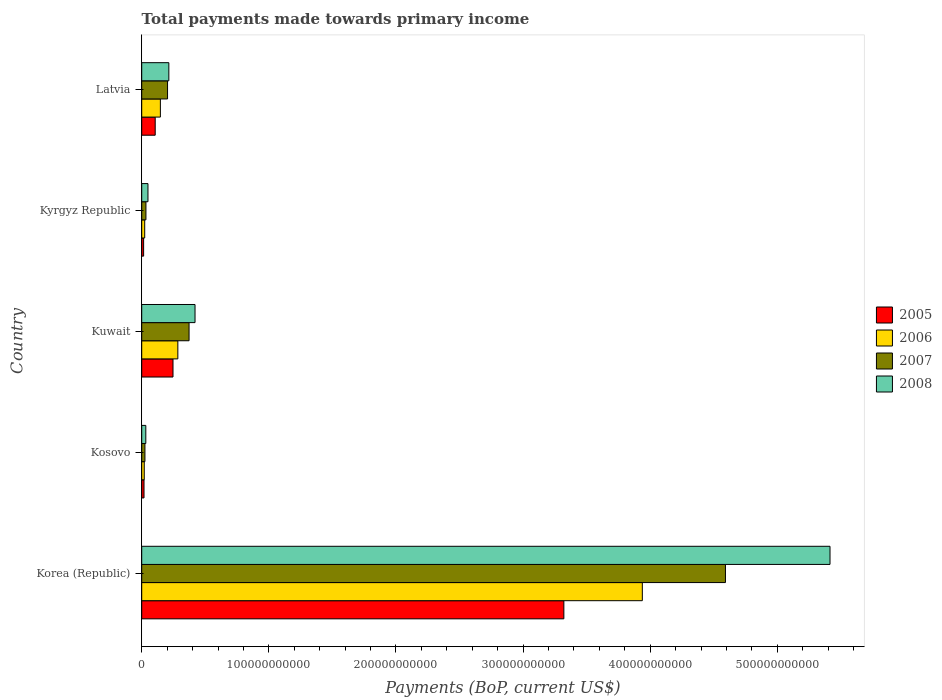How many different coloured bars are there?
Offer a very short reply. 4. How many groups of bars are there?
Ensure brevity in your answer.  5. Are the number of bars on each tick of the Y-axis equal?
Provide a short and direct response. Yes. How many bars are there on the 5th tick from the bottom?
Ensure brevity in your answer.  4. In how many cases, is the number of bars for a given country not equal to the number of legend labels?
Make the answer very short. 0. What is the total payments made towards primary income in 2006 in Kyrgyz Republic?
Ensure brevity in your answer.  2.34e+09. Across all countries, what is the maximum total payments made towards primary income in 2005?
Ensure brevity in your answer.  3.32e+11. Across all countries, what is the minimum total payments made towards primary income in 2007?
Provide a succinct answer. 2.53e+09. In which country was the total payments made towards primary income in 2006 minimum?
Your answer should be very brief. Kosovo. What is the total total payments made towards primary income in 2008 in the graph?
Offer a terse response. 6.13e+11. What is the difference between the total payments made towards primary income in 2007 in Kosovo and that in Latvia?
Keep it short and to the point. -1.78e+1. What is the difference between the total payments made towards primary income in 2005 in Korea (Republic) and the total payments made towards primary income in 2008 in Latvia?
Provide a succinct answer. 3.11e+11. What is the average total payments made towards primary income in 2006 per country?
Your answer should be compact. 8.82e+1. What is the difference between the total payments made towards primary income in 2006 and total payments made towards primary income in 2005 in Kyrgyz Republic?
Provide a short and direct response. 8.41e+08. What is the ratio of the total payments made towards primary income in 2008 in Korea (Republic) to that in Kuwait?
Your answer should be very brief. 12.91. Is the difference between the total payments made towards primary income in 2006 in Kosovo and Latvia greater than the difference between the total payments made towards primary income in 2005 in Kosovo and Latvia?
Keep it short and to the point. No. What is the difference between the highest and the second highest total payments made towards primary income in 2007?
Offer a very short reply. 4.22e+11. What is the difference between the highest and the lowest total payments made towards primary income in 2008?
Give a very brief answer. 5.38e+11. Is the sum of the total payments made towards primary income in 2008 in Kuwait and Latvia greater than the maximum total payments made towards primary income in 2006 across all countries?
Offer a very short reply. No. Is it the case that in every country, the sum of the total payments made towards primary income in 2005 and total payments made towards primary income in 2008 is greater than the sum of total payments made towards primary income in 2007 and total payments made towards primary income in 2006?
Your answer should be very brief. No. What does the 2nd bar from the bottom in Kosovo represents?
Offer a terse response. 2006. Is it the case that in every country, the sum of the total payments made towards primary income in 2008 and total payments made towards primary income in 2007 is greater than the total payments made towards primary income in 2005?
Offer a terse response. Yes. How many bars are there?
Your answer should be compact. 20. What is the difference between two consecutive major ticks on the X-axis?
Keep it short and to the point. 1.00e+11. Does the graph contain any zero values?
Give a very brief answer. No. Does the graph contain grids?
Your answer should be very brief. No. How are the legend labels stacked?
Provide a short and direct response. Vertical. What is the title of the graph?
Your answer should be very brief. Total payments made towards primary income. What is the label or title of the X-axis?
Your answer should be very brief. Payments (BoP, current US$). What is the label or title of the Y-axis?
Your answer should be compact. Country. What is the Payments (BoP, current US$) in 2005 in Korea (Republic)?
Keep it short and to the point. 3.32e+11. What is the Payments (BoP, current US$) in 2006 in Korea (Republic)?
Offer a very short reply. 3.94e+11. What is the Payments (BoP, current US$) in 2007 in Korea (Republic)?
Make the answer very short. 4.59e+11. What is the Payments (BoP, current US$) of 2008 in Korea (Republic)?
Make the answer very short. 5.41e+11. What is the Payments (BoP, current US$) of 2005 in Kosovo?
Give a very brief answer. 1.80e+09. What is the Payments (BoP, current US$) of 2006 in Kosovo?
Your answer should be compact. 1.99e+09. What is the Payments (BoP, current US$) in 2007 in Kosovo?
Provide a succinct answer. 2.53e+09. What is the Payments (BoP, current US$) of 2008 in Kosovo?
Offer a terse response. 3.22e+09. What is the Payments (BoP, current US$) in 2005 in Kuwait?
Provide a succinct answer. 2.46e+1. What is the Payments (BoP, current US$) in 2006 in Kuwait?
Ensure brevity in your answer.  2.84e+1. What is the Payments (BoP, current US$) of 2007 in Kuwait?
Offer a terse response. 3.72e+1. What is the Payments (BoP, current US$) in 2008 in Kuwait?
Provide a succinct answer. 4.19e+1. What is the Payments (BoP, current US$) of 2005 in Kyrgyz Republic?
Offer a very short reply. 1.50e+09. What is the Payments (BoP, current US$) in 2006 in Kyrgyz Republic?
Ensure brevity in your answer.  2.34e+09. What is the Payments (BoP, current US$) in 2007 in Kyrgyz Republic?
Provide a short and direct response. 3.31e+09. What is the Payments (BoP, current US$) in 2008 in Kyrgyz Republic?
Provide a succinct answer. 4.91e+09. What is the Payments (BoP, current US$) of 2005 in Latvia?
Offer a terse response. 1.06e+1. What is the Payments (BoP, current US$) in 2006 in Latvia?
Provide a succinct answer. 1.47e+1. What is the Payments (BoP, current US$) of 2007 in Latvia?
Keep it short and to the point. 2.03e+1. What is the Payments (BoP, current US$) in 2008 in Latvia?
Your answer should be compact. 2.13e+1. Across all countries, what is the maximum Payments (BoP, current US$) of 2005?
Provide a succinct answer. 3.32e+11. Across all countries, what is the maximum Payments (BoP, current US$) of 2006?
Provide a short and direct response. 3.94e+11. Across all countries, what is the maximum Payments (BoP, current US$) in 2007?
Give a very brief answer. 4.59e+11. Across all countries, what is the maximum Payments (BoP, current US$) in 2008?
Ensure brevity in your answer.  5.41e+11. Across all countries, what is the minimum Payments (BoP, current US$) in 2005?
Provide a short and direct response. 1.50e+09. Across all countries, what is the minimum Payments (BoP, current US$) in 2006?
Make the answer very short. 1.99e+09. Across all countries, what is the minimum Payments (BoP, current US$) of 2007?
Provide a succinct answer. 2.53e+09. Across all countries, what is the minimum Payments (BoP, current US$) in 2008?
Your response must be concise. 3.22e+09. What is the total Payments (BoP, current US$) in 2005 in the graph?
Your answer should be very brief. 3.71e+11. What is the total Payments (BoP, current US$) of 2006 in the graph?
Ensure brevity in your answer.  4.41e+11. What is the total Payments (BoP, current US$) of 2007 in the graph?
Give a very brief answer. 5.23e+11. What is the total Payments (BoP, current US$) in 2008 in the graph?
Provide a short and direct response. 6.13e+11. What is the difference between the Payments (BoP, current US$) in 2005 in Korea (Republic) and that in Kosovo?
Make the answer very short. 3.30e+11. What is the difference between the Payments (BoP, current US$) in 2006 in Korea (Republic) and that in Kosovo?
Give a very brief answer. 3.92e+11. What is the difference between the Payments (BoP, current US$) in 2007 in Korea (Republic) and that in Kosovo?
Make the answer very short. 4.57e+11. What is the difference between the Payments (BoP, current US$) of 2008 in Korea (Republic) and that in Kosovo?
Give a very brief answer. 5.38e+11. What is the difference between the Payments (BoP, current US$) in 2005 in Korea (Republic) and that in Kuwait?
Offer a terse response. 3.07e+11. What is the difference between the Payments (BoP, current US$) of 2006 in Korea (Republic) and that in Kuwait?
Make the answer very short. 3.65e+11. What is the difference between the Payments (BoP, current US$) of 2007 in Korea (Republic) and that in Kuwait?
Your answer should be very brief. 4.22e+11. What is the difference between the Payments (BoP, current US$) in 2008 in Korea (Republic) and that in Kuwait?
Make the answer very short. 5.00e+11. What is the difference between the Payments (BoP, current US$) of 2005 in Korea (Republic) and that in Kyrgyz Republic?
Make the answer very short. 3.31e+11. What is the difference between the Payments (BoP, current US$) in 2006 in Korea (Republic) and that in Kyrgyz Republic?
Ensure brevity in your answer.  3.91e+11. What is the difference between the Payments (BoP, current US$) in 2007 in Korea (Republic) and that in Kyrgyz Republic?
Offer a very short reply. 4.56e+11. What is the difference between the Payments (BoP, current US$) of 2008 in Korea (Republic) and that in Kyrgyz Republic?
Offer a terse response. 5.37e+11. What is the difference between the Payments (BoP, current US$) in 2005 in Korea (Republic) and that in Latvia?
Offer a terse response. 3.21e+11. What is the difference between the Payments (BoP, current US$) of 2006 in Korea (Republic) and that in Latvia?
Give a very brief answer. 3.79e+11. What is the difference between the Payments (BoP, current US$) of 2007 in Korea (Republic) and that in Latvia?
Your answer should be compact. 4.39e+11. What is the difference between the Payments (BoP, current US$) of 2008 in Korea (Republic) and that in Latvia?
Provide a short and direct response. 5.20e+11. What is the difference between the Payments (BoP, current US$) in 2005 in Kosovo and that in Kuwait?
Your answer should be very brief. -2.28e+1. What is the difference between the Payments (BoP, current US$) of 2006 in Kosovo and that in Kuwait?
Your response must be concise. -2.64e+1. What is the difference between the Payments (BoP, current US$) in 2007 in Kosovo and that in Kuwait?
Keep it short and to the point. -3.47e+1. What is the difference between the Payments (BoP, current US$) of 2008 in Kosovo and that in Kuwait?
Your answer should be very brief. -3.87e+1. What is the difference between the Payments (BoP, current US$) in 2005 in Kosovo and that in Kyrgyz Republic?
Offer a terse response. 3.03e+08. What is the difference between the Payments (BoP, current US$) of 2006 in Kosovo and that in Kyrgyz Republic?
Provide a succinct answer. -3.55e+08. What is the difference between the Payments (BoP, current US$) of 2007 in Kosovo and that in Kyrgyz Republic?
Your answer should be compact. -7.83e+08. What is the difference between the Payments (BoP, current US$) of 2008 in Kosovo and that in Kyrgyz Republic?
Make the answer very short. -1.69e+09. What is the difference between the Payments (BoP, current US$) of 2005 in Kosovo and that in Latvia?
Provide a succinct answer. -8.80e+09. What is the difference between the Payments (BoP, current US$) in 2006 in Kosovo and that in Latvia?
Ensure brevity in your answer.  -1.27e+1. What is the difference between the Payments (BoP, current US$) of 2007 in Kosovo and that in Latvia?
Keep it short and to the point. -1.78e+1. What is the difference between the Payments (BoP, current US$) of 2008 in Kosovo and that in Latvia?
Offer a very short reply. -1.81e+1. What is the difference between the Payments (BoP, current US$) in 2005 in Kuwait and that in Kyrgyz Republic?
Your response must be concise. 2.31e+1. What is the difference between the Payments (BoP, current US$) of 2006 in Kuwait and that in Kyrgyz Republic?
Ensure brevity in your answer.  2.61e+1. What is the difference between the Payments (BoP, current US$) in 2007 in Kuwait and that in Kyrgyz Republic?
Ensure brevity in your answer.  3.39e+1. What is the difference between the Payments (BoP, current US$) of 2008 in Kuwait and that in Kyrgyz Republic?
Offer a very short reply. 3.70e+1. What is the difference between the Payments (BoP, current US$) in 2005 in Kuwait and that in Latvia?
Offer a terse response. 1.40e+1. What is the difference between the Payments (BoP, current US$) of 2006 in Kuwait and that in Latvia?
Make the answer very short. 1.37e+1. What is the difference between the Payments (BoP, current US$) in 2007 in Kuwait and that in Latvia?
Make the answer very short. 1.69e+1. What is the difference between the Payments (BoP, current US$) of 2008 in Kuwait and that in Latvia?
Provide a short and direct response. 2.06e+1. What is the difference between the Payments (BoP, current US$) in 2005 in Kyrgyz Republic and that in Latvia?
Ensure brevity in your answer.  -9.11e+09. What is the difference between the Payments (BoP, current US$) of 2006 in Kyrgyz Republic and that in Latvia?
Your answer should be compact. -1.23e+1. What is the difference between the Payments (BoP, current US$) in 2007 in Kyrgyz Republic and that in Latvia?
Make the answer very short. -1.70e+1. What is the difference between the Payments (BoP, current US$) in 2008 in Kyrgyz Republic and that in Latvia?
Your response must be concise. -1.64e+1. What is the difference between the Payments (BoP, current US$) of 2005 in Korea (Republic) and the Payments (BoP, current US$) of 2006 in Kosovo?
Make the answer very short. 3.30e+11. What is the difference between the Payments (BoP, current US$) in 2005 in Korea (Republic) and the Payments (BoP, current US$) in 2007 in Kosovo?
Ensure brevity in your answer.  3.30e+11. What is the difference between the Payments (BoP, current US$) of 2005 in Korea (Republic) and the Payments (BoP, current US$) of 2008 in Kosovo?
Give a very brief answer. 3.29e+11. What is the difference between the Payments (BoP, current US$) in 2006 in Korea (Republic) and the Payments (BoP, current US$) in 2007 in Kosovo?
Keep it short and to the point. 3.91e+11. What is the difference between the Payments (BoP, current US$) of 2006 in Korea (Republic) and the Payments (BoP, current US$) of 2008 in Kosovo?
Your response must be concise. 3.91e+11. What is the difference between the Payments (BoP, current US$) in 2007 in Korea (Republic) and the Payments (BoP, current US$) in 2008 in Kosovo?
Your response must be concise. 4.56e+11. What is the difference between the Payments (BoP, current US$) in 2005 in Korea (Republic) and the Payments (BoP, current US$) in 2006 in Kuwait?
Your answer should be very brief. 3.04e+11. What is the difference between the Payments (BoP, current US$) of 2005 in Korea (Republic) and the Payments (BoP, current US$) of 2007 in Kuwait?
Your response must be concise. 2.95e+11. What is the difference between the Payments (BoP, current US$) in 2005 in Korea (Republic) and the Payments (BoP, current US$) in 2008 in Kuwait?
Your answer should be compact. 2.90e+11. What is the difference between the Payments (BoP, current US$) in 2006 in Korea (Republic) and the Payments (BoP, current US$) in 2007 in Kuwait?
Give a very brief answer. 3.57e+11. What is the difference between the Payments (BoP, current US$) of 2006 in Korea (Republic) and the Payments (BoP, current US$) of 2008 in Kuwait?
Offer a very short reply. 3.52e+11. What is the difference between the Payments (BoP, current US$) of 2007 in Korea (Republic) and the Payments (BoP, current US$) of 2008 in Kuwait?
Provide a short and direct response. 4.17e+11. What is the difference between the Payments (BoP, current US$) of 2005 in Korea (Republic) and the Payments (BoP, current US$) of 2006 in Kyrgyz Republic?
Your answer should be very brief. 3.30e+11. What is the difference between the Payments (BoP, current US$) of 2005 in Korea (Republic) and the Payments (BoP, current US$) of 2007 in Kyrgyz Republic?
Offer a very short reply. 3.29e+11. What is the difference between the Payments (BoP, current US$) of 2005 in Korea (Republic) and the Payments (BoP, current US$) of 2008 in Kyrgyz Republic?
Give a very brief answer. 3.27e+11. What is the difference between the Payments (BoP, current US$) in 2006 in Korea (Republic) and the Payments (BoP, current US$) in 2007 in Kyrgyz Republic?
Provide a succinct answer. 3.91e+11. What is the difference between the Payments (BoP, current US$) of 2006 in Korea (Republic) and the Payments (BoP, current US$) of 2008 in Kyrgyz Republic?
Offer a very short reply. 3.89e+11. What is the difference between the Payments (BoP, current US$) in 2007 in Korea (Republic) and the Payments (BoP, current US$) in 2008 in Kyrgyz Republic?
Your response must be concise. 4.54e+11. What is the difference between the Payments (BoP, current US$) of 2005 in Korea (Republic) and the Payments (BoP, current US$) of 2006 in Latvia?
Provide a succinct answer. 3.17e+11. What is the difference between the Payments (BoP, current US$) in 2005 in Korea (Republic) and the Payments (BoP, current US$) in 2007 in Latvia?
Provide a short and direct response. 3.12e+11. What is the difference between the Payments (BoP, current US$) in 2005 in Korea (Republic) and the Payments (BoP, current US$) in 2008 in Latvia?
Provide a succinct answer. 3.11e+11. What is the difference between the Payments (BoP, current US$) in 2006 in Korea (Republic) and the Payments (BoP, current US$) in 2007 in Latvia?
Provide a succinct answer. 3.74e+11. What is the difference between the Payments (BoP, current US$) of 2006 in Korea (Republic) and the Payments (BoP, current US$) of 2008 in Latvia?
Make the answer very short. 3.72e+11. What is the difference between the Payments (BoP, current US$) of 2007 in Korea (Republic) and the Payments (BoP, current US$) of 2008 in Latvia?
Make the answer very short. 4.38e+11. What is the difference between the Payments (BoP, current US$) of 2005 in Kosovo and the Payments (BoP, current US$) of 2006 in Kuwait?
Offer a very short reply. -2.66e+1. What is the difference between the Payments (BoP, current US$) in 2005 in Kosovo and the Payments (BoP, current US$) in 2007 in Kuwait?
Your answer should be compact. -3.54e+1. What is the difference between the Payments (BoP, current US$) in 2005 in Kosovo and the Payments (BoP, current US$) in 2008 in Kuwait?
Make the answer very short. -4.01e+1. What is the difference between the Payments (BoP, current US$) of 2006 in Kosovo and the Payments (BoP, current US$) of 2007 in Kuwait?
Provide a succinct answer. -3.53e+1. What is the difference between the Payments (BoP, current US$) of 2006 in Kosovo and the Payments (BoP, current US$) of 2008 in Kuwait?
Give a very brief answer. -3.99e+1. What is the difference between the Payments (BoP, current US$) of 2007 in Kosovo and the Payments (BoP, current US$) of 2008 in Kuwait?
Provide a short and direct response. -3.94e+1. What is the difference between the Payments (BoP, current US$) of 2005 in Kosovo and the Payments (BoP, current US$) of 2006 in Kyrgyz Republic?
Your response must be concise. -5.39e+08. What is the difference between the Payments (BoP, current US$) of 2005 in Kosovo and the Payments (BoP, current US$) of 2007 in Kyrgyz Republic?
Your response must be concise. -1.51e+09. What is the difference between the Payments (BoP, current US$) of 2005 in Kosovo and the Payments (BoP, current US$) of 2008 in Kyrgyz Republic?
Your answer should be very brief. -3.11e+09. What is the difference between the Payments (BoP, current US$) of 2006 in Kosovo and the Payments (BoP, current US$) of 2007 in Kyrgyz Republic?
Provide a short and direct response. -1.32e+09. What is the difference between the Payments (BoP, current US$) of 2006 in Kosovo and the Payments (BoP, current US$) of 2008 in Kyrgyz Republic?
Your answer should be very brief. -2.93e+09. What is the difference between the Payments (BoP, current US$) in 2007 in Kosovo and the Payments (BoP, current US$) in 2008 in Kyrgyz Republic?
Offer a very short reply. -2.38e+09. What is the difference between the Payments (BoP, current US$) in 2005 in Kosovo and the Payments (BoP, current US$) in 2006 in Latvia?
Give a very brief answer. -1.29e+1. What is the difference between the Payments (BoP, current US$) of 2005 in Kosovo and the Payments (BoP, current US$) of 2007 in Latvia?
Offer a terse response. -1.85e+1. What is the difference between the Payments (BoP, current US$) in 2005 in Kosovo and the Payments (BoP, current US$) in 2008 in Latvia?
Ensure brevity in your answer.  -1.95e+1. What is the difference between the Payments (BoP, current US$) in 2006 in Kosovo and the Payments (BoP, current US$) in 2007 in Latvia?
Keep it short and to the point. -1.83e+1. What is the difference between the Payments (BoP, current US$) of 2006 in Kosovo and the Payments (BoP, current US$) of 2008 in Latvia?
Offer a very short reply. -1.93e+1. What is the difference between the Payments (BoP, current US$) of 2007 in Kosovo and the Payments (BoP, current US$) of 2008 in Latvia?
Your response must be concise. -1.88e+1. What is the difference between the Payments (BoP, current US$) of 2005 in Kuwait and the Payments (BoP, current US$) of 2006 in Kyrgyz Republic?
Provide a succinct answer. 2.23e+1. What is the difference between the Payments (BoP, current US$) of 2005 in Kuwait and the Payments (BoP, current US$) of 2007 in Kyrgyz Republic?
Your answer should be very brief. 2.13e+1. What is the difference between the Payments (BoP, current US$) in 2005 in Kuwait and the Payments (BoP, current US$) in 2008 in Kyrgyz Republic?
Offer a very short reply. 1.97e+1. What is the difference between the Payments (BoP, current US$) of 2006 in Kuwait and the Payments (BoP, current US$) of 2007 in Kyrgyz Republic?
Provide a short and direct response. 2.51e+1. What is the difference between the Payments (BoP, current US$) of 2006 in Kuwait and the Payments (BoP, current US$) of 2008 in Kyrgyz Republic?
Provide a short and direct response. 2.35e+1. What is the difference between the Payments (BoP, current US$) of 2007 in Kuwait and the Payments (BoP, current US$) of 2008 in Kyrgyz Republic?
Your answer should be very brief. 3.23e+1. What is the difference between the Payments (BoP, current US$) of 2005 in Kuwait and the Payments (BoP, current US$) of 2006 in Latvia?
Make the answer very short. 9.93e+09. What is the difference between the Payments (BoP, current US$) in 2005 in Kuwait and the Payments (BoP, current US$) in 2007 in Latvia?
Provide a succinct answer. 4.30e+09. What is the difference between the Payments (BoP, current US$) in 2005 in Kuwait and the Payments (BoP, current US$) in 2008 in Latvia?
Provide a succinct answer. 3.28e+09. What is the difference between the Payments (BoP, current US$) of 2006 in Kuwait and the Payments (BoP, current US$) of 2007 in Latvia?
Provide a short and direct response. 8.10e+09. What is the difference between the Payments (BoP, current US$) in 2006 in Kuwait and the Payments (BoP, current US$) in 2008 in Latvia?
Ensure brevity in your answer.  7.08e+09. What is the difference between the Payments (BoP, current US$) in 2007 in Kuwait and the Payments (BoP, current US$) in 2008 in Latvia?
Your response must be concise. 1.59e+1. What is the difference between the Payments (BoP, current US$) in 2005 in Kyrgyz Republic and the Payments (BoP, current US$) in 2006 in Latvia?
Give a very brief answer. -1.32e+1. What is the difference between the Payments (BoP, current US$) in 2005 in Kyrgyz Republic and the Payments (BoP, current US$) in 2007 in Latvia?
Keep it short and to the point. -1.88e+1. What is the difference between the Payments (BoP, current US$) in 2005 in Kyrgyz Republic and the Payments (BoP, current US$) in 2008 in Latvia?
Offer a terse response. -1.98e+1. What is the difference between the Payments (BoP, current US$) in 2006 in Kyrgyz Republic and the Payments (BoP, current US$) in 2007 in Latvia?
Provide a succinct answer. -1.80e+1. What is the difference between the Payments (BoP, current US$) in 2006 in Kyrgyz Republic and the Payments (BoP, current US$) in 2008 in Latvia?
Offer a very short reply. -1.90e+1. What is the difference between the Payments (BoP, current US$) in 2007 in Kyrgyz Republic and the Payments (BoP, current US$) in 2008 in Latvia?
Offer a very short reply. -1.80e+1. What is the average Payments (BoP, current US$) in 2005 per country?
Your answer should be compact. 7.41e+1. What is the average Payments (BoP, current US$) in 2006 per country?
Offer a terse response. 8.82e+1. What is the average Payments (BoP, current US$) of 2007 per country?
Keep it short and to the point. 1.05e+11. What is the average Payments (BoP, current US$) in 2008 per country?
Your answer should be compact. 1.23e+11. What is the difference between the Payments (BoP, current US$) in 2005 and Payments (BoP, current US$) in 2006 in Korea (Republic)?
Offer a very short reply. -6.17e+1. What is the difference between the Payments (BoP, current US$) of 2005 and Payments (BoP, current US$) of 2007 in Korea (Republic)?
Your response must be concise. -1.27e+11. What is the difference between the Payments (BoP, current US$) in 2005 and Payments (BoP, current US$) in 2008 in Korea (Republic)?
Give a very brief answer. -2.09e+11. What is the difference between the Payments (BoP, current US$) of 2006 and Payments (BoP, current US$) of 2007 in Korea (Republic)?
Ensure brevity in your answer.  -6.54e+1. What is the difference between the Payments (BoP, current US$) in 2006 and Payments (BoP, current US$) in 2008 in Korea (Republic)?
Offer a terse response. -1.48e+11. What is the difference between the Payments (BoP, current US$) of 2007 and Payments (BoP, current US$) of 2008 in Korea (Republic)?
Offer a terse response. -8.22e+1. What is the difference between the Payments (BoP, current US$) in 2005 and Payments (BoP, current US$) in 2006 in Kosovo?
Provide a succinct answer. -1.83e+08. What is the difference between the Payments (BoP, current US$) in 2005 and Payments (BoP, current US$) in 2007 in Kosovo?
Provide a succinct answer. -7.24e+08. What is the difference between the Payments (BoP, current US$) in 2005 and Payments (BoP, current US$) in 2008 in Kosovo?
Make the answer very short. -1.42e+09. What is the difference between the Payments (BoP, current US$) in 2006 and Payments (BoP, current US$) in 2007 in Kosovo?
Keep it short and to the point. -5.41e+08. What is the difference between the Payments (BoP, current US$) in 2006 and Payments (BoP, current US$) in 2008 in Kosovo?
Offer a very short reply. -1.24e+09. What is the difference between the Payments (BoP, current US$) of 2007 and Payments (BoP, current US$) of 2008 in Kosovo?
Your answer should be compact. -6.94e+08. What is the difference between the Payments (BoP, current US$) of 2005 and Payments (BoP, current US$) of 2006 in Kuwait?
Provide a succinct answer. -3.80e+09. What is the difference between the Payments (BoP, current US$) of 2005 and Payments (BoP, current US$) of 2007 in Kuwait?
Your answer should be very brief. -1.26e+1. What is the difference between the Payments (BoP, current US$) in 2005 and Payments (BoP, current US$) in 2008 in Kuwait?
Keep it short and to the point. -1.73e+1. What is the difference between the Payments (BoP, current US$) of 2006 and Payments (BoP, current US$) of 2007 in Kuwait?
Ensure brevity in your answer.  -8.83e+09. What is the difference between the Payments (BoP, current US$) in 2006 and Payments (BoP, current US$) in 2008 in Kuwait?
Your response must be concise. -1.35e+1. What is the difference between the Payments (BoP, current US$) of 2007 and Payments (BoP, current US$) of 2008 in Kuwait?
Provide a succinct answer. -4.70e+09. What is the difference between the Payments (BoP, current US$) in 2005 and Payments (BoP, current US$) in 2006 in Kyrgyz Republic?
Make the answer very short. -8.41e+08. What is the difference between the Payments (BoP, current US$) in 2005 and Payments (BoP, current US$) in 2007 in Kyrgyz Republic?
Offer a terse response. -1.81e+09. What is the difference between the Payments (BoP, current US$) in 2005 and Payments (BoP, current US$) in 2008 in Kyrgyz Republic?
Offer a terse response. -3.41e+09. What is the difference between the Payments (BoP, current US$) in 2006 and Payments (BoP, current US$) in 2007 in Kyrgyz Republic?
Provide a succinct answer. -9.69e+08. What is the difference between the Payments (BoP, current US$) in 2006 and Payments (BoP, current US$) in 2008 in Kyrgyz Republic?
Ensure brevity in your answer.  -2.57e+09. What is the difference between the Payments (BoP, current US$) in 2007 and Payments (BoP, current US$) in 2008 in Kyrgyz Republic?
Your answer should be compact. -1.60e+09. What is the difference between the Payments (BoP, current US$) in 2005 and Payments (BoP, current US$) in 2006 in Latvia?
Your answer should be compact. -4.07e+09. What is the difference between the Payments (BoP, current US$) of 2005 and Payments (BoP, current US$) of 2007 in Latvia?
Provide a succinct answer. -9.71e+09. What is the difference between the Payments (BoP, current US$) in 2005 and Payments (BoP, current US$) in 2008 in Latvia?
Your response must be concise. -1.07e+1. What is the difference between the Payments (BoP, current US$) of 2006 and Payments (BoP, current US$) of 2007 in Latvia?
Make the answer very short. -5.63e+09. What is the difference between the Payments (BoP, current US$) in 2006 and Payments (BoP, current US$) in 2008 in Latvia?
Make the answer very short. -6.65e+09. What is the difference between the Payments (BoP, current US$) in 2007 and Payments (BoP, current US$) in 2008 in Latvia?
Your response must be concise. -1.02e+09. What is the ratio of the Payments (BoP, current US$) in 2005 in Korea (Republic) to that in Kosovo?
Keep it short and to the point. 184.13. What is the ratio of the Payments (BoP, current US$) in 2006 in Korea (Republic) to that in Kosovo?
Give a very brief answer. 198.25. What is the ratio of the Payments (BoP, current US$) in 2007 in Korea (Republic) to that in Kosovo?
Give a very brief answer. 181.66. What is the ratio of the Payments (BoP, current US$) in 2008 in Korea (Republic) to that in Kosovo?
Keep it short and to the point. 168.03. What is the ratio of the Payments (BoP, current US$) of 2005 in Korea (Republic) to that in Kuwait?
Keep it short and to the point. 13.49. What is the ratio of the Payments (BoP, current US$) of 2006 in Korea (Republic) to that in Kuwait?
Offer a terse response. 13.86. What is the ratio of the Payments (BoP, current US$) in 2007 in Korea (Republic) to that in Kuwait?
Provide a short and direct response. 12.33. What is the ratio of the Payments (BoP, current US$) of 2008 in Korea (Republic) to that in Kuwait?
Keep it short and to the point. 12.91. What is the ratio of the Payments (BoP, current US$) of 2005 in Korea (Republic) to that in Kyrgyz Republic?
Keep it short and to the point. 221.31. What is the ratio of the Payments (BoP, current US$) in 2006 in Korea (Republic) to that in Kyrgyz Republic?
Provide a short and direct response. 168.16. What is the ratio of the Payments (BoP, current US$) of 2007 in Korea (Republic) to that in Kyrgyz Republic?
Your answer should be very brief. 138.68. What is the ratio of the Payments (BoP, current US$) in 2008 in Korea (Republic) to that in Kyrgyz Republic?
Provide a succinct answer. 110.24. What is the ratio of the Payments (BoP, current US$) of 2005 in Korea (Republic) to that in Latvia?
Provide a succinct answer. 31.31. What is the ratio of the Payments (BoP, current US$) in 2006 in Korea (Republic) to that in Latvia?
Give a very brief answer. 26.83. What is the ratio of the Payments (BoP, current US$) of 2007 in Korea (Republic) to that in Latvia?
Keep it short and to the point. 22.61. What is the ratio of the Payments (BoP, current US$) in 2008 in Korea (Republic) to that in Latvia?
Offer a very short reply. 25.38. What is the ratio of the Payments (BoP, current US$) of 2005 in Kosovo to that in Kuwait?
Your answer should be very brief. 0.07. What is the ratio of the Payments (BoP, current US$) of 2006 in Kosovo to that in Kuwait?
Your answer should be compact. 0.07. What is the ratio of the Payments (BoP, current US$) of 2007 in Kosovo to that in Kuwait?
Your answer should be very brief. 0.07. What is the ratio of the Payments (BoP, current US$) in 2008 in Kosovo to that in Kuwait?
Make the answer very short. 0.08. What is the ratio of the Payments (BoP, current US$) of 2005 in Kosovo to that in Kyrgyz Republic?
Offer a very short reply. 1.2. What is the ratio of the Payments (BoP, current US$) in 2006 in Kosovo to that in Kyrgyz Republic?
Ensure brevity in your answer.  0.85. What is the ratio of the Payments (BoP, current US$) in 2007 in Kosovo to that in Kyrgyz Republic?
Ensure brevity in your answer.  0.76. What is the ratio of the Payments (BoP, current US$) of 2008 in Kosovo to that in Kyrgyz Republic?
Your answer should be very brief. 0.66. What is the ratio of the Payments (BoP, current US$) in 2005 in Kosovo to that in Latvia?
Give a very brief answer. 0.17. What is the ratio of the Payments (BoP, current US$) of 2006 in Kosovo to that in Latvia?
Provide a short and direct response. 0.14. What is the ratio of the Payments (BoP, current US$) of 2007 in Kosovo to that in Latvia?
Your response must be concise. 0.12. What is the ratio of the Payments (BoP, current US$) in 2008 in Kosovo to that in Latvia?
Provide a succinct answer. 0.15. What is the ratio of the Payments (BoP, current US$) of 2005 in Kuwait to that in Kyrgyz Republic?
Offer a terse response. 16.4. What is the ratio of the Payments (BoP, current US$) of 2006 in Kuwait to that in Kyrgyz Republic?
Provide a short and direct response. 12.13. What is the ratio of the Payments (BoP, current US$) in 2007 in Kuwait to that in Kyrgyz Republic?
Provide a succinct answer. 11.25. What is the ratio of the Payments (BoP, current US$) of 2008 in Kuwait to that in Kyrgyz Republic?
Ensure brevity in your answer.  8.54. What is the ratio of the Payments (BoP, current US$) in 2005 in Kuwait to that in Latvia?
Provide a succinct answer. 2.32. What is the ratio of the Payments (BoP, current US$) in 2006 in Kuwait to that in Latvia?
Offer a terse response. 1.94. What is the ratio of the Payments (BoP, current US$) of 2007 in Kuwait to that in Latvia?
Give a very brief answer. 1.83. What is the ratio of the Payments (BoP, current US$) of 2008 in Kuwait to that in Latvia?
Offer a very short reply. 1.97. What is the ratio of the Payments (BoP, current US$) in 2005 in Kyrgyz Republic to that in Latvia?
Offer a terse response. 0.14. What is the ratio of the Payments (BoP, current US$) of 2006 in Kyrgyz Republic to that in Latvia?
Ensure brevity in your answer.  0.16. What is the ratio of the Payments (BoP, current US$) of 2007 in Kyrgyz Republic to that in Latvia?
Your response must be concise. 0.16. What is the ratio of the Payments (BoP, current US$) of 2008 in Kyrgyz Republic to that in Latvia?
Keep it short and to the point. 0.23. What is the difference between the highest and the second highest Payments (BoP, current US$) of 2005?
Provide a short and direct response. 3.07e+11. What is the difference between the highest and the second highest Payments (BoP, current US$) in 2006?
Keep it short and to the point. 3.65e+11. What is the difference between the highest and the second highest Payments (BoP, current US$) of 2007?
Offer a very short reply. 4.22e+11. What is the difference between the highest and the second highest Payments (BoP, current US$) of 2008?
Your response must be concise. 5.00e+11. What is the difference between the highest and the lowest Payments (BoP, current US$) in 2005?
Ensure brevity in your answer.  3.31e+11. What is the difference between the highest and the lowest Payments (BoP, current US$) of 2006?
Keep it short and to the point. 3.92e+11. What is the difference between the highest and the lowest Payments (BoP, current US$) of 2007?
Provide a succinct answer. 4.57e+11. What is the difference between the highest and the lowest Payments (BoP, current US$) in 2008?
Give a very brief answer. 5.38e+11. 